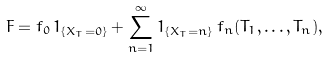<formula> <loc_0><loc_0><loc_500><loc_500>F = f _ { 0 } \, 1 _ { \{ X _ { T } = 0 \} } + \sum _ { n = 1 } ^ { \infty } 1 _ { \{ X _ { T } = n \} } \, f _ { n } ( T _ { 1 } , \dots , T _ { n } ) ,</formula> 